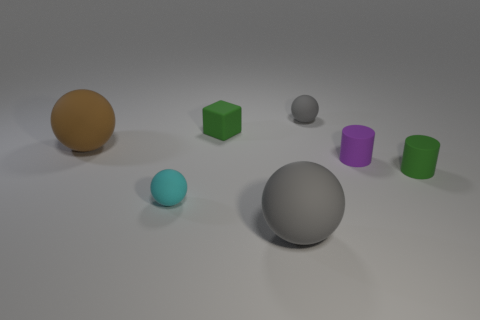Add 1 large gray matte balls. How many objects exist? 8 Subtract all small gray matte spheres. How many spheres are left? 3 Subtract all cubes. How many objects are left? 6 Subtract all gray spheres. How many spheres are left? 2 Subtract all cyan cubes. Subtract all blue cylinders. How many cubes are left? 1 Subtract all blue spheres. How many green cylinders are left? 1 Subtract all tiny green cubes. Subtract all small gray things. How many objects are left? 5 Add 2 green cubes. How many green cubes are left? 3 Add 4 small gray things. How many small gray things exist? 5 Subtract 1 green cylinders. How many objects are left? 6 